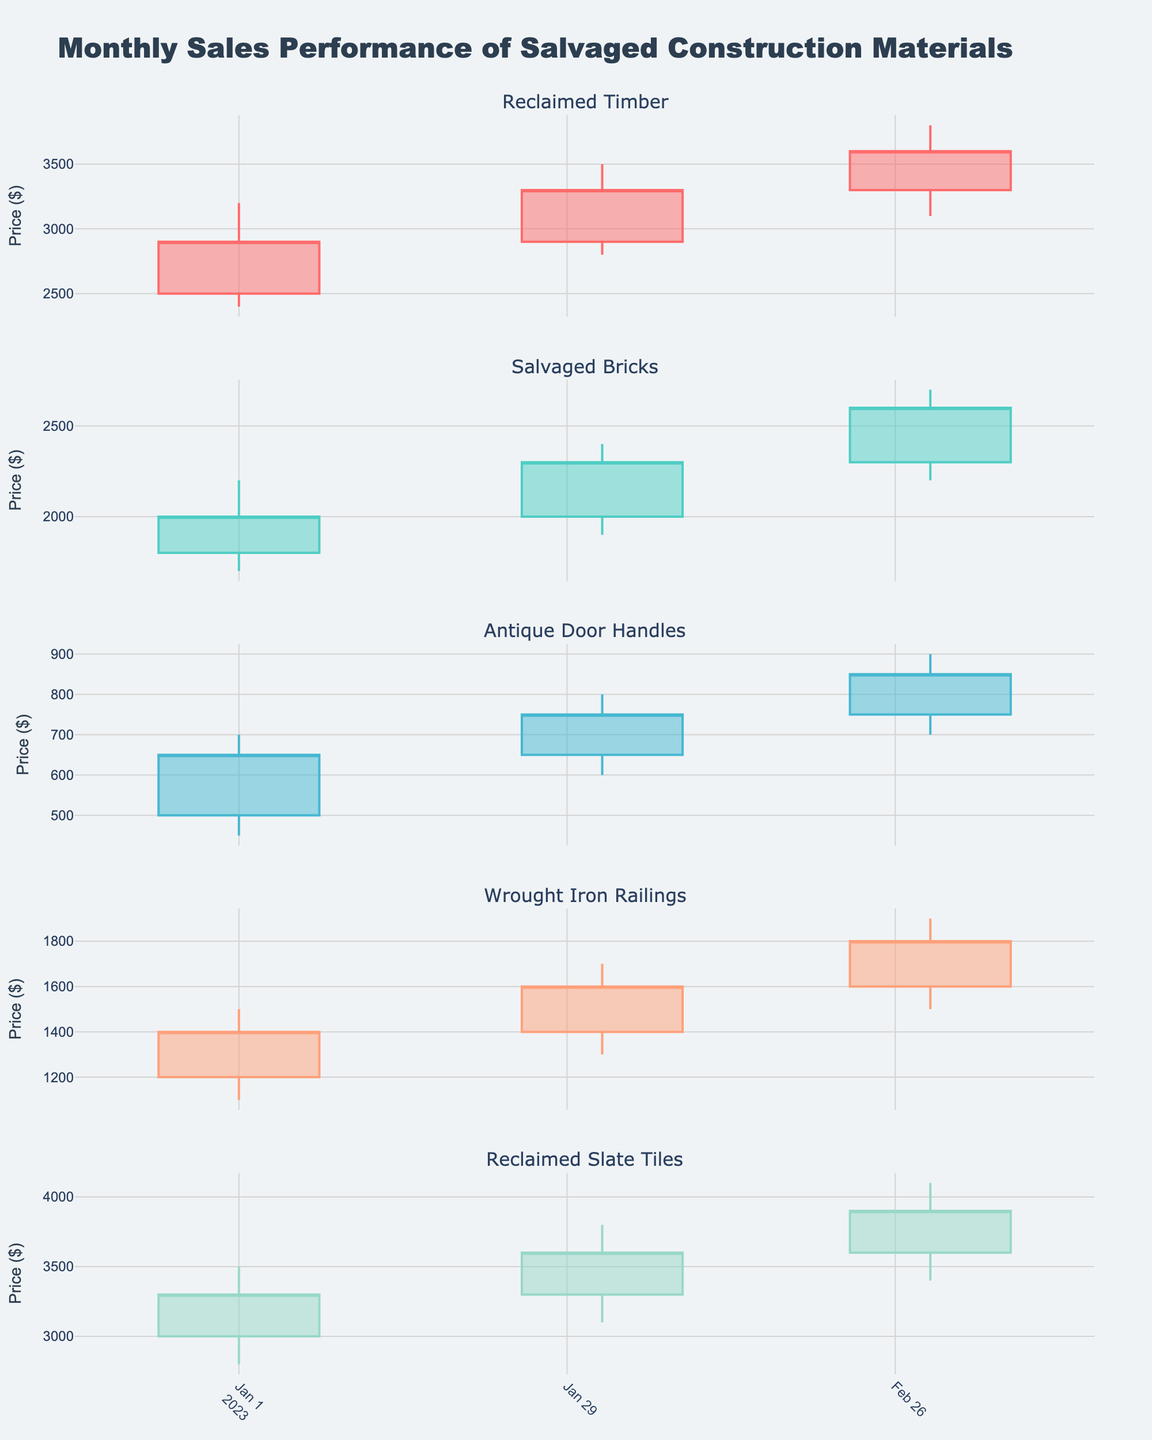What's the title of the chart? The title of the chart is prominently displayed at the top. It reads "Monthly Sales Performance of Salvaged Construction Materials".
Answer: Monthly Sales Performance of Salvaged Construction Materials What materials are shown in the chart? Each subplot in the chart is titled with the name of the salvaged material being represented. The materials include Reclaimed Timber, Salvaged Bricks, Antique Door Handles, Wrought Iron Railings, and Reclaimed Slate Tiles.
Answer: Reclaimed Timber, Salvaged Bricks, Antique Door Handles, Wrought Iron Railings, Reclaimed Slate Tiles Which salvaged material had the highest closing price in January 2023? Observing the data points for January 2023 across all the subplots, Reclaimed Slate Tiles had the highest closing price of $3300.
Answer: Reclaimed Slate Tiles How did the closing price of Antique Door Handles change from January to March 2023? In January 2023, the closing price was $650. In February 2023, it rose to $750. By March 2023, it increased further to $850. So the closing price steadily increased each month.
Answer: Increased Compare the February closing prices of Reclaimed Timber and Salvaged Bricks. Which one is higher? For February 2023, Reclaimed Timber's closing price is $3300, while Salvaged Bricks' closing price is $2300. Therefore, Reclaimed Timber's closing price is higher.
Answer: Reclaimed Timber What was the trend in the high prices for Wrought Iron Railings from January to March 2023? The high prices for Wrought Iron Railings increased from $1500 in January to $1700 in February, and then to $1900 in March 2023. This shows a consistent upward trend.
Answer: Upward trend What is the difference in the low price of Reclaimed Timber between January and March 2023? The low price of Reclaimed Timber was $2400 in January and $3100 in March 2023. The difference is calculated as $3100 - $2400 = $700.
Answer: $700 Which material showed the highest volatility in March 2023 based on the range between high and low prices? Volatility is measured by the range between high and low prices. For March 2023, Reclaimed Timber had a range of $3800 - $3100 = $700, Salvaged Bricks had $2700 - $2200 = $500, Antique Door Handles had $900 - $700 = $200, Wrought Iron Railings had $1900 - $1500 = $400, and Reclaimed Slate Tiles had $4100 - $3400 = $700. Both Reclaimed Timber and Reclaimed Slate Tiles showed the highest volatility.
Answer: Reclaimed Timber and Reclaimed Slate Tiles 